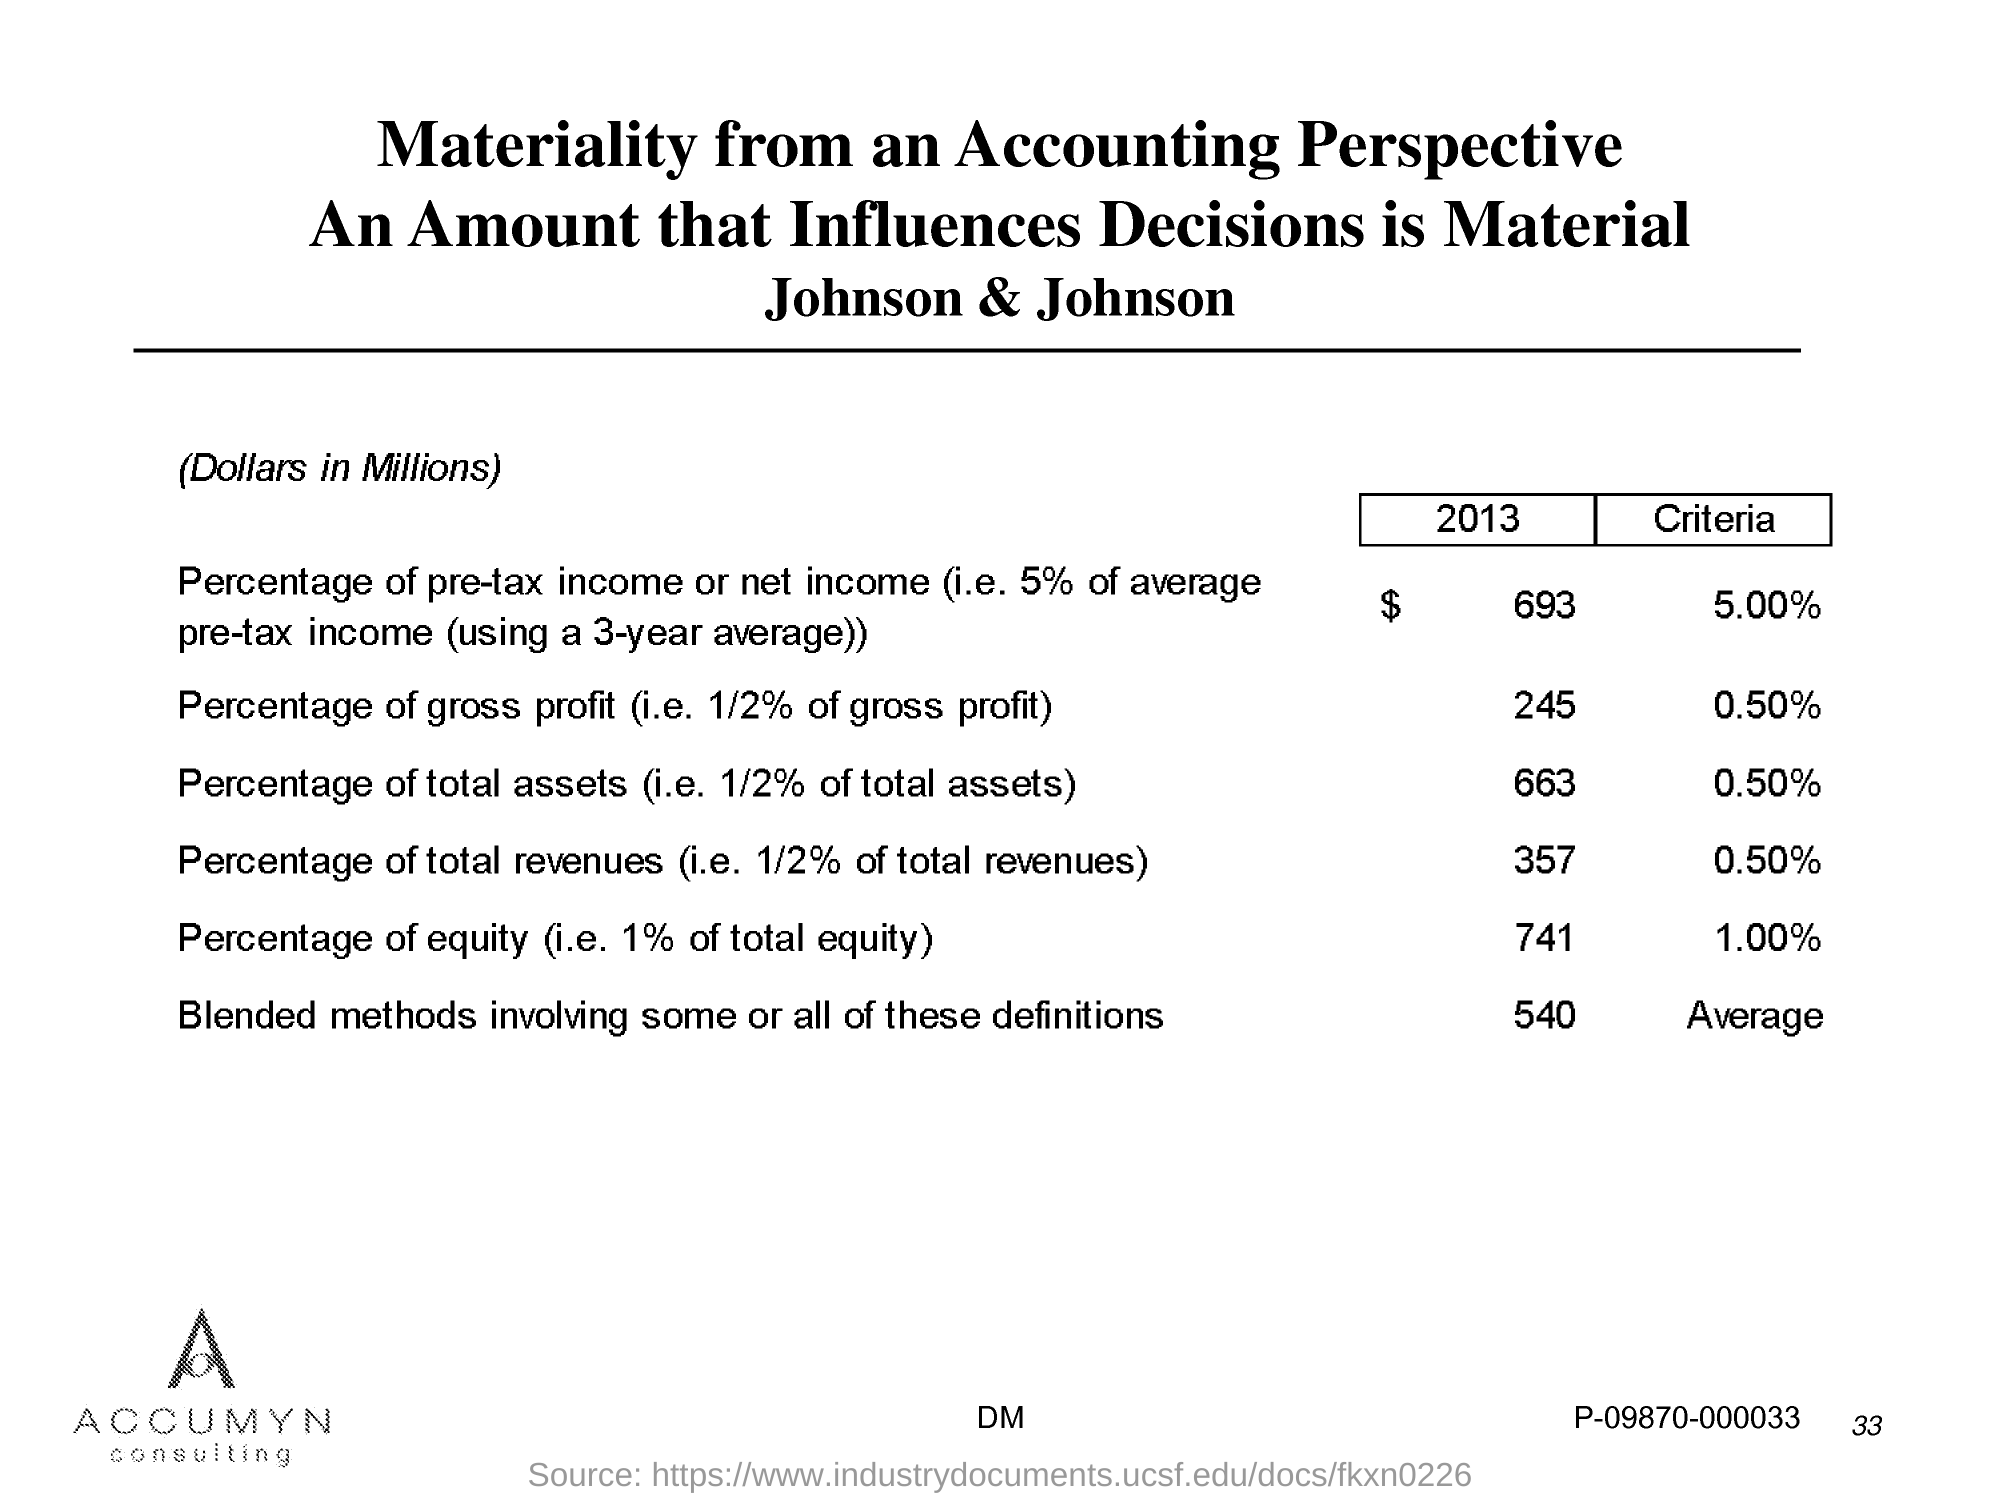What is the Page Number?
 33 